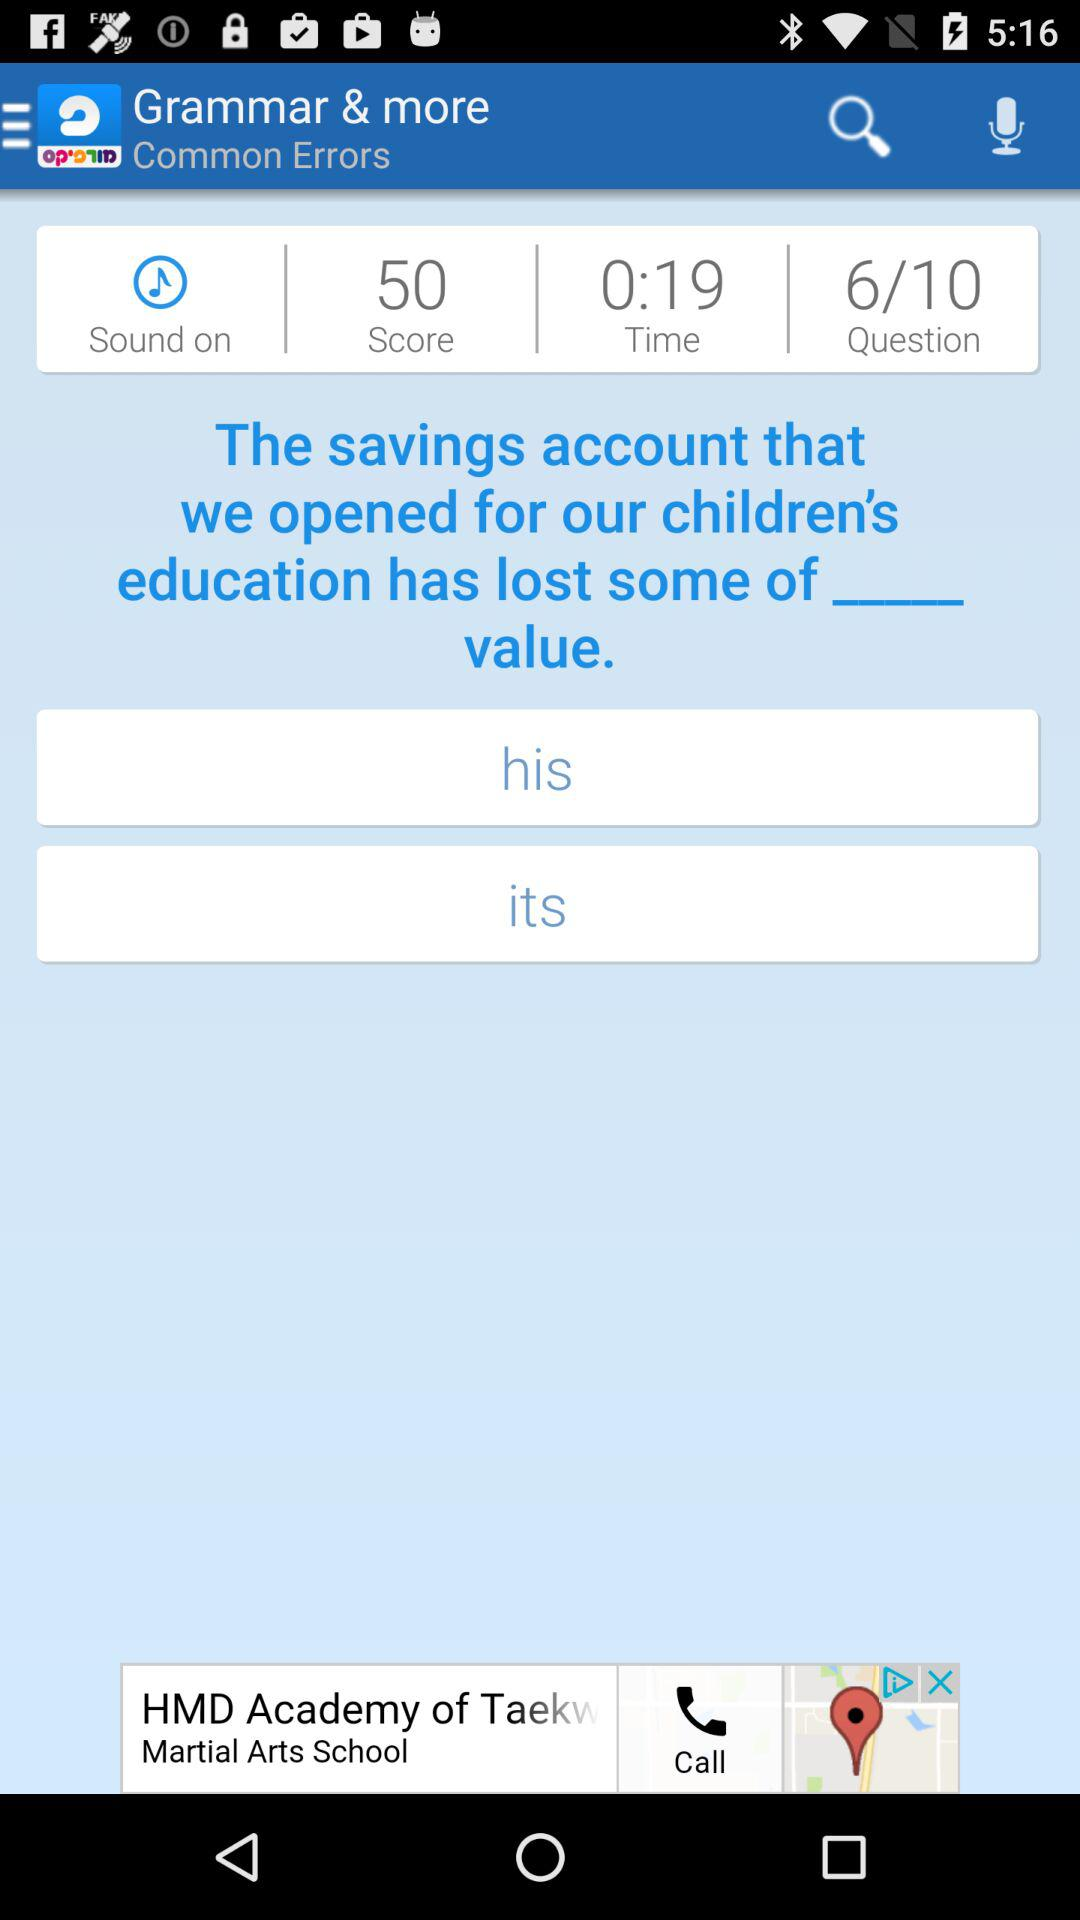What is the time? The time is 19 seconds. 